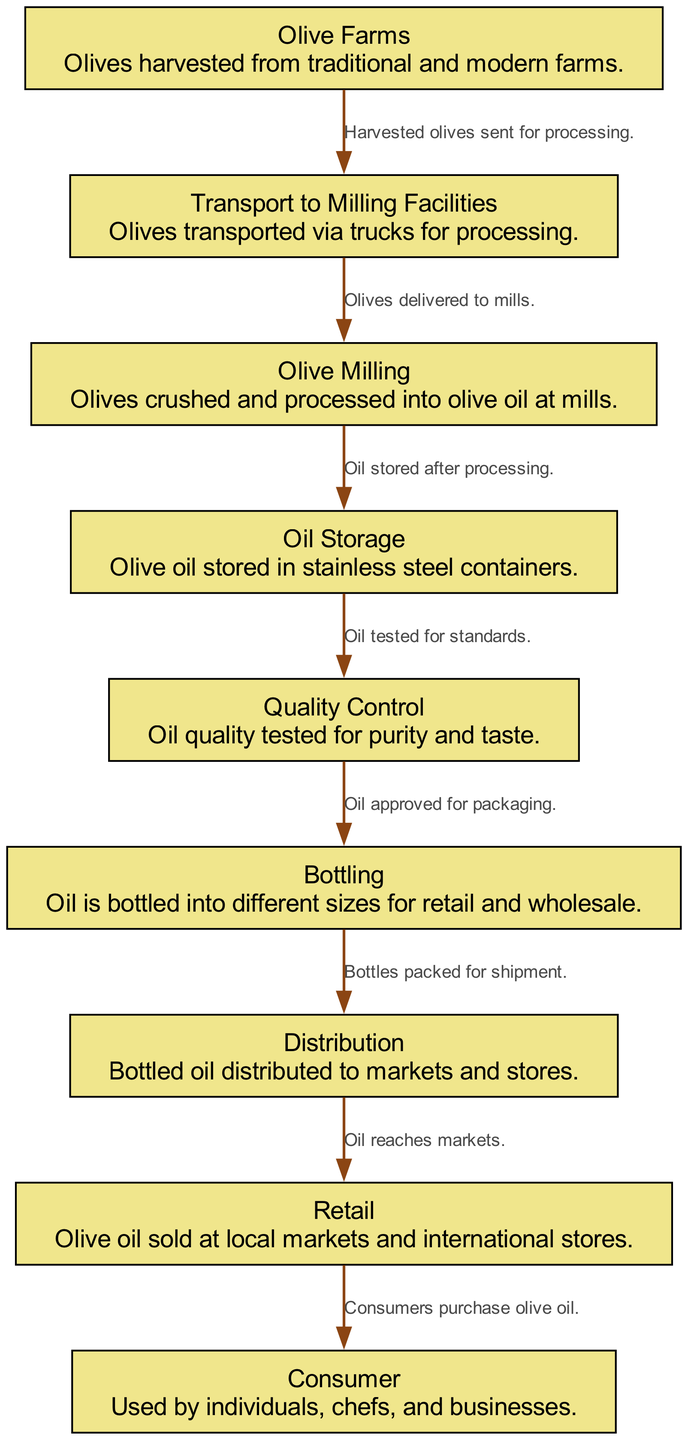What is the first stage in the olive oil production chain? The first stage is "Olive Farms," where olives are harvested. This is the starting point of the entire production process.
Answer: Olive Farms What follows after "Transport to Milling Facilities"? The stage that directly follows "Transport to Milling Facilities" is "Olive Milling," where olives are processed into olive oil. This connection indicates the flow of olives from transport to processing.
Answer: Olive Milling How many total elements are in the diagram? By counting each distinct node listed in the "elements" data, we find there are nine specific elements making up the entire production chain.
Answer: Nine What is checked during the "Quality Control" stage? During the "Quality Control" stage, the purity and taste of the oil are tested to ensure it meets specific standards before moving to bottling.
Answer: Purity and taste Which stage comes after "Oil Storage"? Following "Oil Storage," the next stage is "Quality Control," where the oil is assessed for its quality. This shows the sequential flow from storage to quality assurance.
Answer: Quality Control What does the "Bottling" stage involve? The "Bottling" stage involves packaging the olive oil into different sizes for retail and wholesale distribution, indicating the transition from production to market readiness.
Answer: Packaging What is the final link in the olive oil production chain? The final link in the chain is the "Consumer," where the olive oil is purchased by individuals, chefs, and businesses, completing the flow from production to consumption.
Answer: Consumer How does "Distribution" relate to "Retail"? "Distribution" connects to "Retail," indicating that the bottled oil is delivered to markets and stores for sale. This shows the relationship between distributing the product and making it available to consumers.
Answer: Delivered to markets What type of facilities are used to store the oil? The oil is stored in "stainless steel containers," which indicate the material used in storage to maintain oil quality.
Answer: Stainless steel containers 